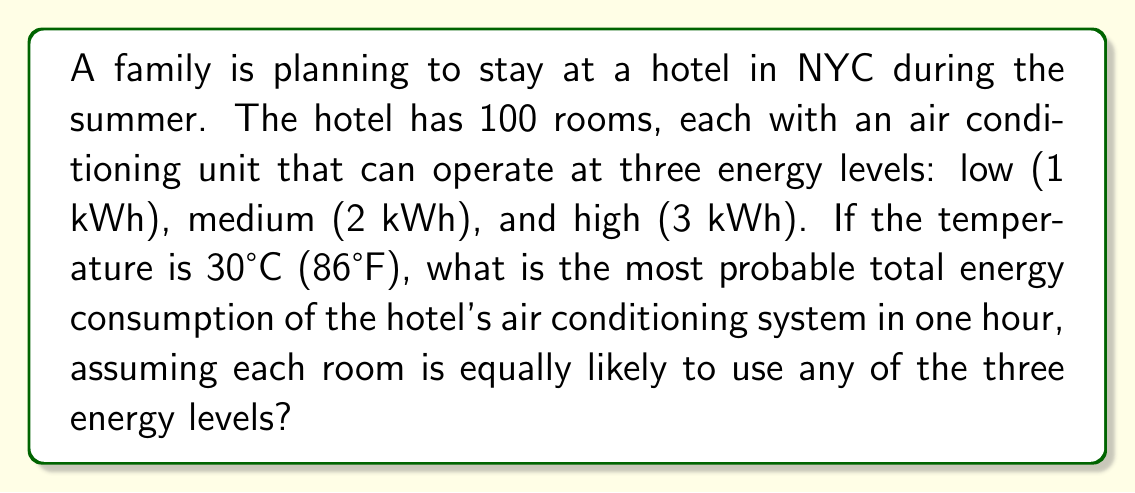Give your solution to this math problem. To solve this problem, we'll use concepts from statistical mechanics, specifically the partition function and the principle of maximum entropy.

Step 1: Define the partition function
The partition function Z for a single room is:
$$Z = e^{-\beta E_1} + e^{-\beta E_2} + e^{-\beta E_3}$$
where $\beta = \frac{1}{k_BT}$, $k_B$ is Boltzmann's constant, and T is temperature.

Step 2: Calculate probabilities
Since all energy levels are equally likely, we can assume $\beta = 0$. This gives:
$$Z = 1 + 1 + 1 = 3$$
The probability of each energy level is:
$$p_1 = p_2 = p_3 = \frac{1}{3}$$

Step 3: Calculate expected energy consumption for one room
$$E_{room} = 1 \cdot \frac{1}{3} + 2 \cdot \frac{1}{3} + 3 \cdot \frac{1}{3} = 2 \text{ kWh}$$

Step 4: Calculate total expected energy consumption
For 100 rooms:
$$E_{total} = 100 \cdot 2 = 200 \text{ kWh}$$

The most probable total energy consumption is equal to the expected value in this case, due to the law of large numbers and the principle of maximum entropy.
Answer: 200 kWh 